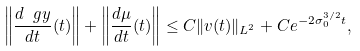<formula> <loc_0><loc_0><loc_500><loc_500>\left \| \frac { d \ g y } { d t } ( t ) \right \| + \left \| \frac { d \mu } { d t } ( t ) \right \| \leq C \| v ( t ) \| _ { L ^ { 2 } } + C e ^ { - 2 \sigma _ { 0 } ^ { 3 / 2 } t } ,</formula> 